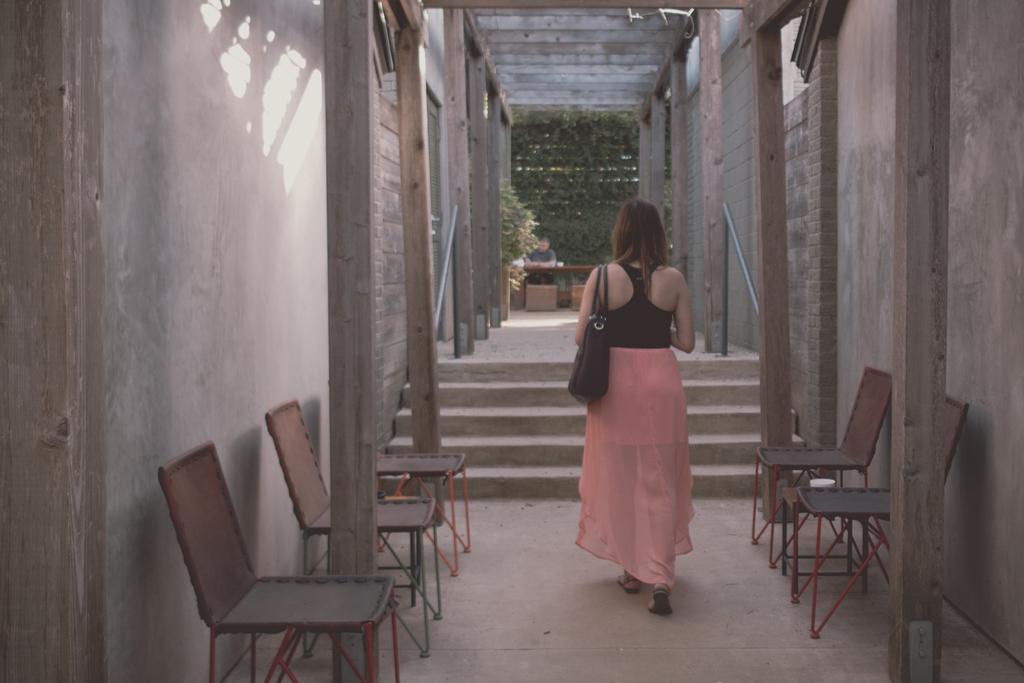Can you describe this image briefly? In the image there is a woman in black vest and pink skirt walking, there are chairs on either side of her in front of the wall and in front of her there are steps, and over the background there is a person sitting in front of table with a plant in front of him. 